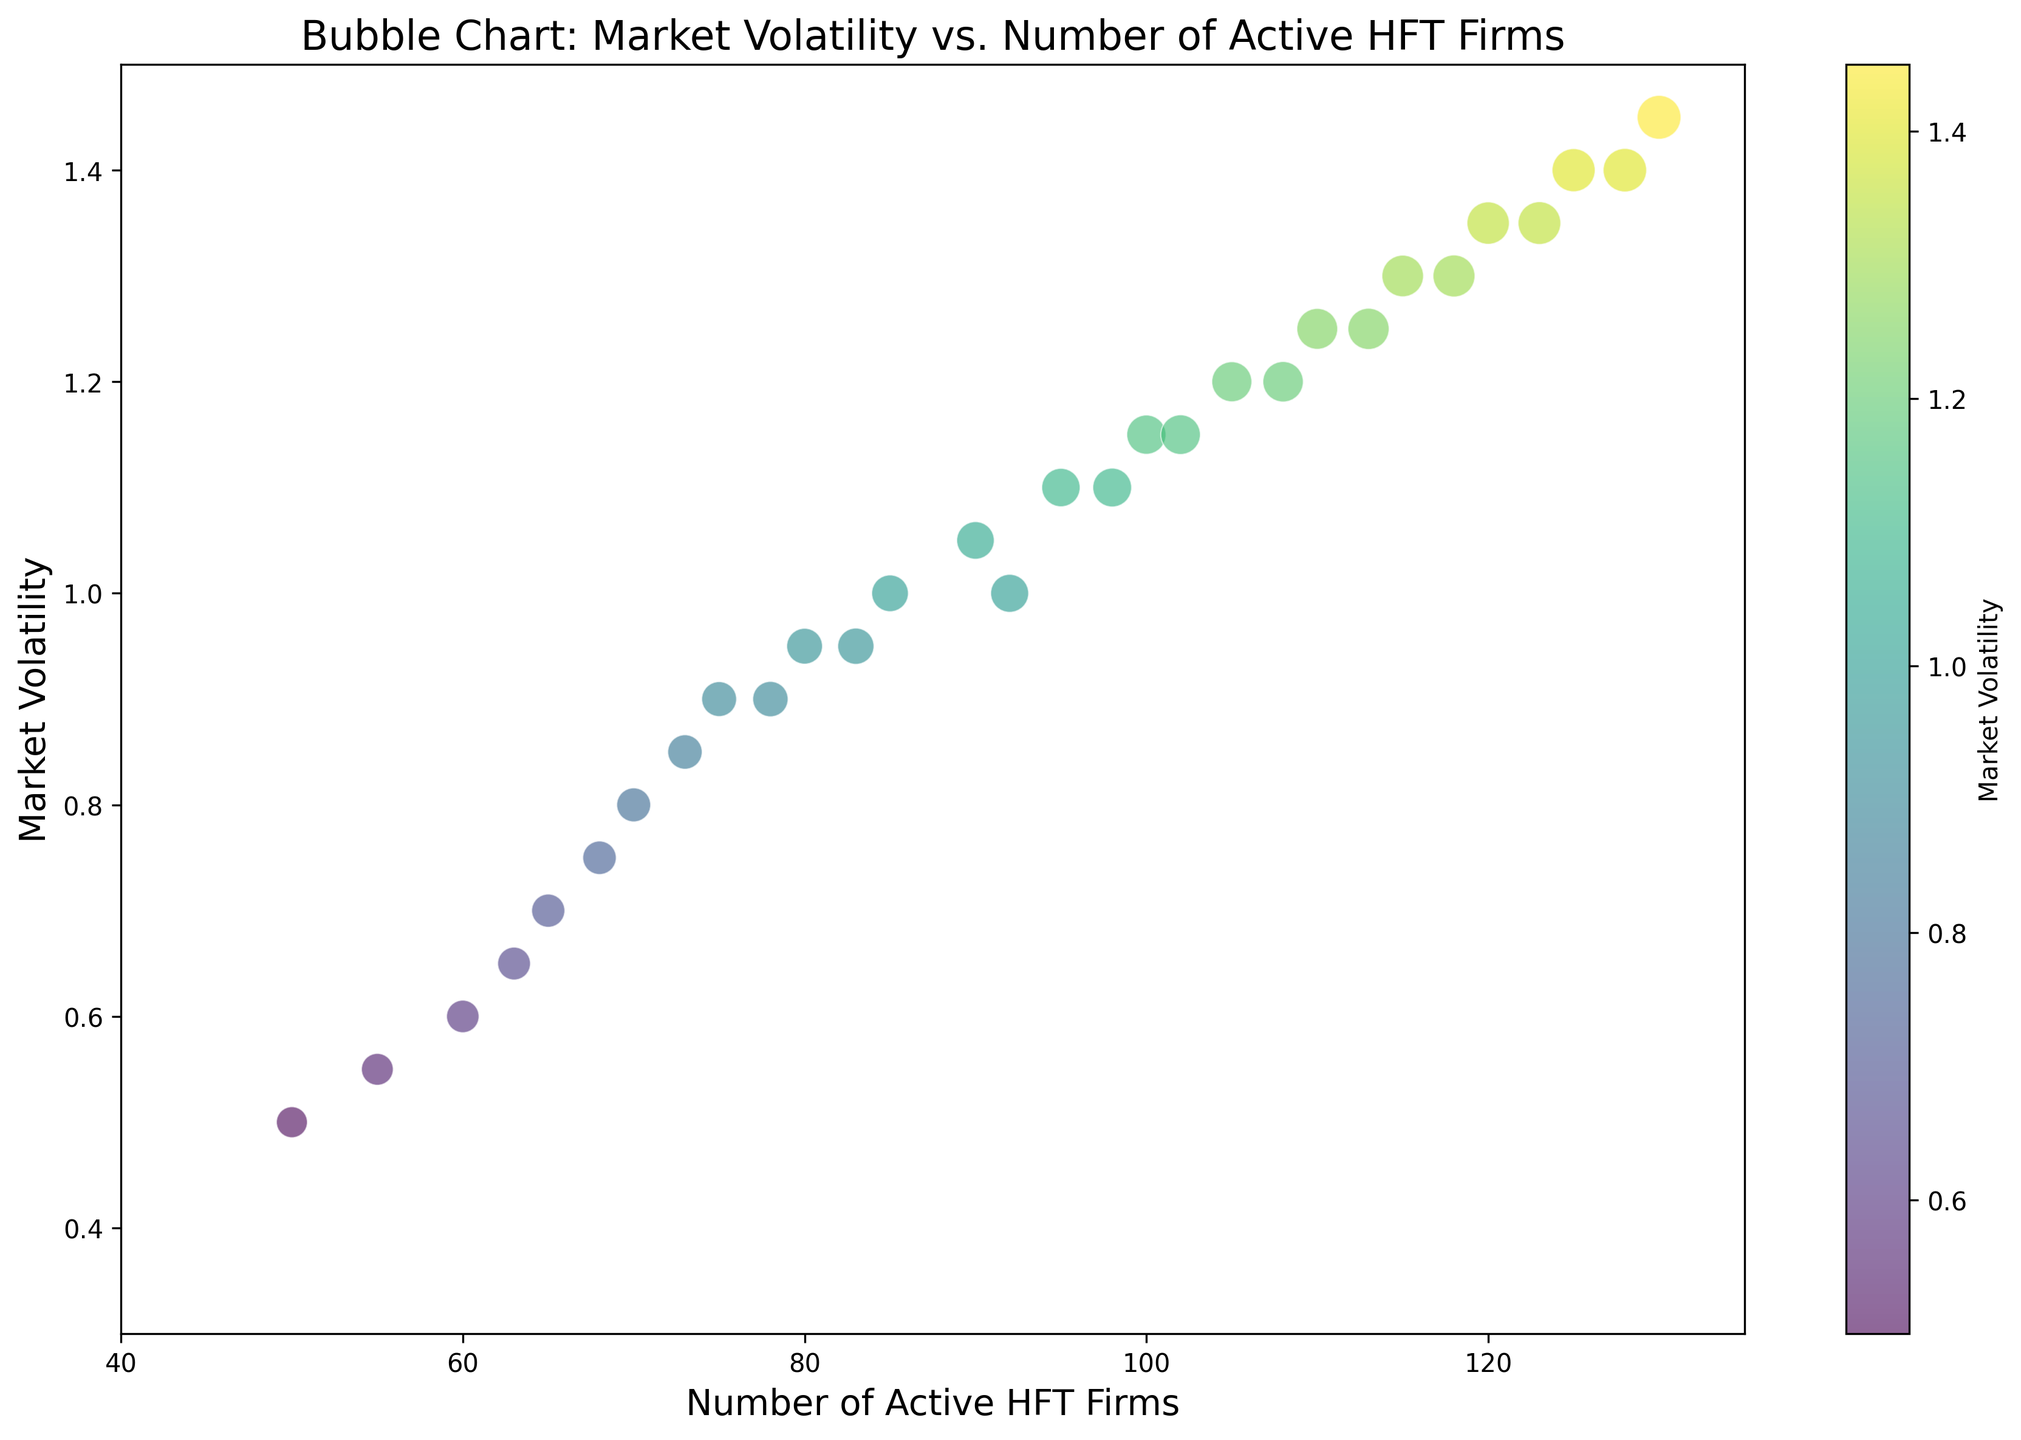What's the range of Market Volatility observed in the figure? To find the range of Market Volatility, identify the minimum and maximum values on the y-axis. The minimum volatility is 0.5, and the maximum volatility is 1.4. The range is the difference between the maximum and minimum values: 1.4 - 0.5.
Answer: 0.9 Which point represents the highest number of Active HFT firms? Look for the point farthest to the right on the x-axis, as this represents the highest number of Active HFT firms. The highest number of Active HFT firms is 130, and this occurs on 2023-01-29.
Answer: 130 Which date has the highest Market Volatility, and what is its value? Identify the highest point on the y-axis. This corresponds to the maximum Market Volatility observed in the data. The highest Market Volatility is on 2023-01-29, with a value of 1.4.
Answer: 2023-01-29, 1.4 What is the average Market Volatility for dates with more than 100 active HFT firms? First, identify dates with more than 100 active HFT firms. The dates are 2023-01-19 to 2023-01-30. Their Market Volatilities are: 1.2, 1.15, 1.25, 1.2, 1.3, 1.25, 1.35, 1.3, 1.4, 1.35, 1.45, and 1.4. Sum these values and divide by the number of dates: (1.2 + 1.15 + 1.25 + 1.2 + 1.3 + 1.25 + 1.35 + 1.3 + 1.4 + 1.35 + 1.45 + 1.4) / 12.
Answer: 1.308 How does the Average Trade Volume visually affect the bubble sizes in the chart? The bubble sizes are proportional to the Average Trade Volume; larger bubbles indicate higher trade volumes. Observe the points with significantly larger bubbles: they correspond to higher Average Trade Volumes.
Answer: Larger bubbles represent higher trade volumes Which two dates have the closest Market Volatility but a different number of active HFT firms? Compare the y-axis values of each point. The dates with the closest Market Volatility are 2023-01-27 and 2023-01-28, both approximately 1.35, but with a different number of active HFT firms, 125 and 123, respectively.
Answer: 2023-01-27 and 2023-01-28 Is there a visible trend between the Number of Active HFT Firms and Market Volatility? Observe the general direction of the points in the scatter plot. A positive correlation means both values tend to increase together, and a negative correlation means one increases as the other decreases. The points generally show an upward trend, indicating a positive correlation.
Answer: Positive correlation Identify the date with the smallest bubble size and provide its Average Trade Volume. The smallest bubble represents the lowest Average Trade Volume. Identify the smallest bubble on the plot and trace it back to the corresponding date. The date is 2023-01-01, and the Average Trade Volume is 1500000.
Answer: 2023-01-01, 1500000 What is the Market Volatility for the date with the highest Average Trade Volume? Identify the largest bubble, which indicates the highest Average Trade Volume. Trace it back to the date and its corresponding Market Volatility. The highest Average Trade Volume is on 2023-01-29, with a Market Volatility of 1.45.
Answer: 1.45 